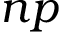<formula> <loc_0><loc_0><loc_500><loc_500>n p</formula> 